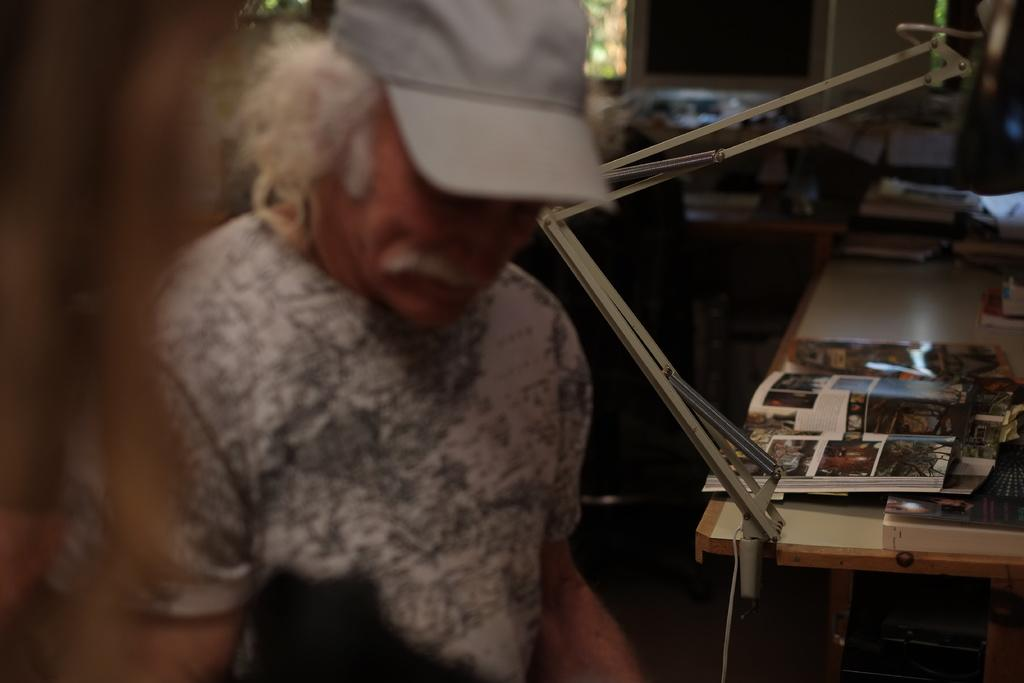Who or what is present in the image? There is a person in the image. What is the person holding or interacting with? There is a book in the image, which suggests that the person might be holding or interacting with it. What else can be seen in the image besides the person and the book? There are other objects in the image, but their specific details are not mentioned in the provided facts. What can be seen in the background of the image? There is a wall and a window in the background of the image, along with other objects. How does the girl end her reading session in the image? There is no girl present in the image, and therefore no reading session to end. 